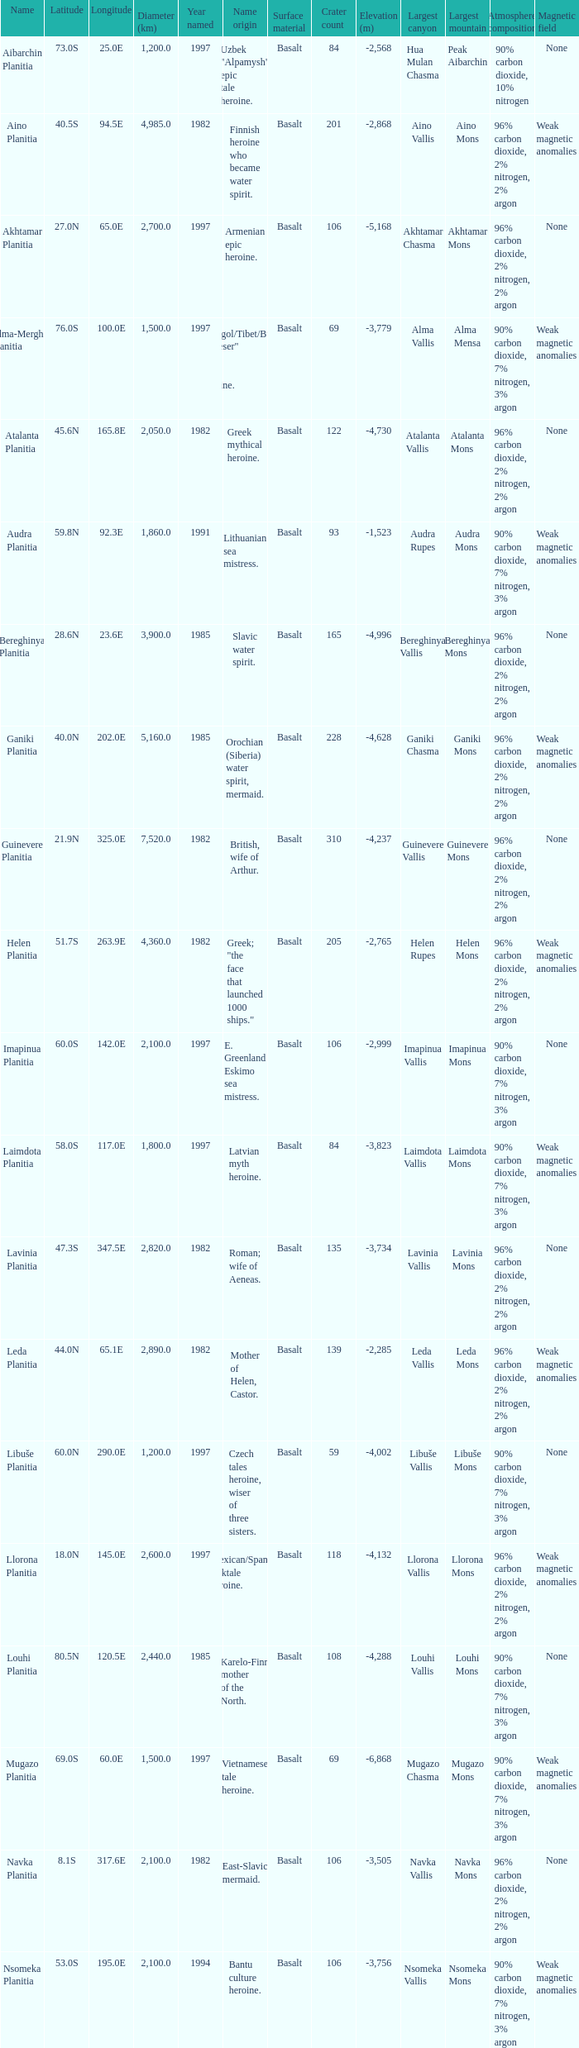For the feature found at a latitude of 23.0s, what is its diameter measured in kilometers? 3000.0. 